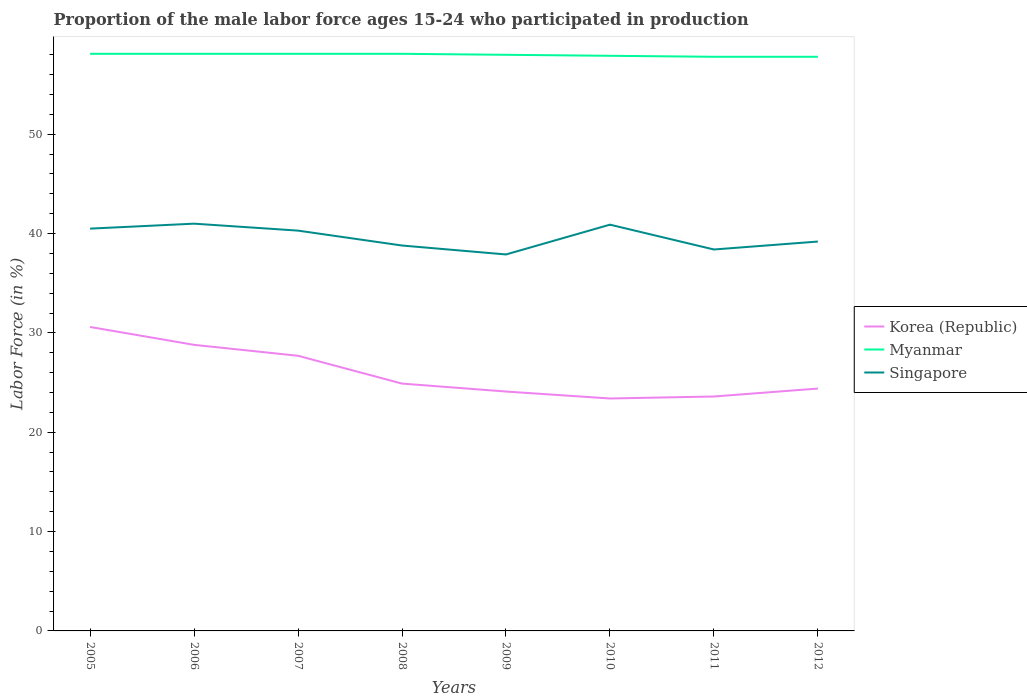How many different coloured lines are there?
Your response must be concise. 3. Is the number of lines equal to the number of legend labels?
Give a very brief answer. Yes. Across all years, what is the maximum proportion of the male labor force who participated in production in Singapore?
Provide a succinct answer. 37.9. In which year was the proportion of the male labor force who participated in production in Korea (Republic) maximum?
Keep it short and to the point. 2010. What is the difference between the highest and the second highest proportion of the male labor force who participated in production in Singapore?
Offer a very short reply. 3.1. Is the proportion of the male labor force who participated in production in Myanmar strictly greater than the proportion of the male labor force who participated in production in Singapore over the years?
Make the answer very short. No. How many lines are there?
Your answer should be compact. 3. Where does the legend appear in the graph?
Provide a short and direct response. Center right. How are the legend labels stacked?
Provide a short and direct response. Vertical. What is the title of the graph?
Keep it short and to the point. Proportion of the male labor force ages 15-24 who participated in production. Does "East Asia (all income levels)" appear as one of the legend labels in the graph?
Offer a terse response. No. What is the label or title of the X-axis?
Provide a short and direct response. Years. What is the label or title of the Y-axis?
Offer a very short reply. Labor Force (in %). What is the Labor Force (in %) of Korea (Republic) in 2005?
Offer a very short reply. 30.6. What is the Labor Force (in %) of Myanmar in 2005?
Your response must be concise. 58.1. What is the Labor Force (in %) of Singapore in 2005?
Provide a succinct answer. 40.5. What is the Labor Force (in %) of Korea (Republic) in 2006?
Your response must be concise. 28.8. What is the Labor Force (in %) of Myanmar in 2006?
Offer a terse response. 58.1. What is the Labor Force (in %) of Korea (Republic) in 2007?
Your answer should be very brief. 27.7. What is the Labor Force (in %) in Myanmar in 2007?
Ensure brevity in your answer.  58.1. What is the Labor Force (in %) of Singapore in 2007?
Provide a short and direct response. 40.3. What is the Labor Force (in %) in Korea (Republic) in 2008?
Give a very brief answer. 24.9. What is the Labor Force (in %) of Myanmar in 2008?
Offer a very short reply. 58.1. What is the Labor Force (in %) of Singapore in 2008?
Your response must be concise. 38.8. What is the Labor Force (in %) in Korea (Republic) in 2009?
Provide a succinct answer. 24.1. What is the Labor Force (in %) of Singapore in 2009?
Make the answer very short. 37.9. What is the Labor Force (in %) of Korea (Republic) in 2010?
Provide a short and direct response. 23.4. What is the Labor Force (in %) of Myanmar in 2010?
Your answer should be very brief. 57.9. What is the Labor Force (in %) in Singapore in 2010?
Give a very brief answer. 40.9. What is the Labor Force (in %) of Korea (Republic) in 2011?
Make the answer very short. 23.6. What is the Labor Force (in %) in Myanmar in 2011?
Provide a succinct answer. 57.8. What is the Labor Force (in %) in Singapore in 2011?
Offer a terse response. 38.4. What is the Labor Force (in %) in Korea (Republic) in 2012?
Your response must be concise. 24.4. What is the Labor Force (in %) in Myanmar in 2012?
Give a very brief answer. 57.8. What is the Labor Force (in %) of Singapore in 2012?
Provide a succinct answer. 39.2. Across all years, what is the maximum Labor Force (in %) of Korea (Republic)?
Offer a very short reply. 30.6. Across all years, what is the maximum Labor Force (in %) in Myanmar?
Provide a short and direct response. 58.1. Across all years, what is the minimum Labor Force (in %) in Korea (Republic)?
Keep it short and to the point. 23.4. Across all years, what is the minimum Labor Force (in %) in Myanmar?
Provide a succinct answer. 57.8. Across all years, what is the minimum Labor Force (in %) in Singapore?
Offer a very short reply. 37.9. What is the total Labor Force (in %) in Korea (Republic) in the graph?
Your answer should be very brief. 207.5. What is the total Labor Force (in %) in Myanmar in the graph?
Ensure brevity in your answer.  463.9. What is the total Labor Force (in %) of Singapore in the graph?
Keep it short and to the point. 317. What is the difference between the Labor Force (in %) in Singapore in 2005 and that in 2006?
Your answer should be very brief. -0.5. What is the difference between the Labor Force (in %) in Singapore in 2005 and that in 2007?
Offer a very short reply. 0.2. What is the difference between the Labor Force (in %) of Myanmar in 2005 and that in 2009?
Provide a succinct answer. 0.1. What is the difference between the Labor Force (in %) in Singapore in 2005 and that in 2009?
Provide a succinct answer. 2.6. What is the difference between the Labor Force (in %) in Korea (Republic) in 2005 and that in 2010?
Provide a succinct answer. 7.2. What is the difference between the Labor Force (in %) of Korea (Republic) in 2005 and that in 2011?
Your answer should be very brief. 7. What is the difference between the Labor Force (in %) of Myanmar in 2005 and that in 2011?
Make the answer very short. 0.3. What is the difference between the Labor Force (in %) of Korea (Republic) in 2005 and that in 2012?
Provide a short and direct response. 6.2. What is the difference between the Labor Force (in %) in Myanmar in 2005 and that in 2012?
Provide a succinct answer. 0.3. What is the difference between the Labor Force (in %) in Singapore in 2005 and that in 2012?
Provide a short and direct response. 1.3. What is the difference between the Labor Force (in %) in Korea (Republic) in 2006 and that in 2007?
Offer a terse response. 1.1. What is the difference between the Labor Force (in %) of Singapore in 2006 and that in 2007?
Give a very brief answer. 0.7. What is the difference between the Labor Force (in %) in Korea (Republic) in 2006 and that in 2009?
Offer a very short reply. 4.7. What is the difference between the Labor Force (in %) of Myanmar in 2006 and that in 2009?
Your answer should be very brief. 0.1. What is the difference between the Labor Force (in %) of Korea (Republic) in 2006 and that in 2010?
Ensure brevity in your answer.  5.4. What is the difference between the Labor Force (in %) in Myanmar in 2006 and that in 2010?
Your answer should be compact. 0.2. What is the difference between the Labor Force (in %) of Myanmar in 2006 and that in 2011?
Offer a terse response. 0.3. What is the difference between the Labor Force (in %) of Korea (Republic) in 2006 and that in 2012?
Your answer should be very brief. 4.4. What is the difference between the Labor Force (in %) of Korea (Republic) in 2007 and that in 2008?
Offer a very short reply. 2.8. What is the difference between the Labor Force (in %) in Myanmar in 2007 and that in 2009?
Provide a succinct answer. 0.1. What is the difference between the Labor Force (in %) of Korea (Republic) in 2007 and that in 2010?
Ensure brevity in your answer.  4.3. What is the difference between the Labor Force (in %) in Korea (Republic) in 2007 and that in 2011?
Give a very brief answer. 4.1. What is the difference between the Labor Force (in %) in Myanmar in 2007 and that in 2011?
Your answer should be very brief. 0.3. What is the difference between the Labor Force (in %) in Korea (Republic) in 2007 and that in 2012?
Make the answer very short. 3.3. What is the difference between the Labor Force (in %) in Singapore in 2007 and that in 2012?
Give a very brief answer. 1.1. What is the difference between the Labor Force (in %) in Singapore in 2008 and that in 2009?
Keep it short and to the point. 0.9. What is the difference between the Labor Force (in %) in Korea (Republic) in 2008 and that in 2010?
Ensure brevity in your answer.  1.5. What is the difference between the Labor Force (in %) in Korea (Republic) in 2008 and that in 2011?
Keep it short and to the point. 1.3. What is the difference between the Labor Force (in %) of Singapore in 2008 and that in 2011?
Provide a succinct answer. 0.4. What is the difference between the Labor Force (in %) in Korea (Republic) in 2008 and that in 2012?
Your response must be concise. 0.5. What is the difference between the Labor Force (in %) of Myanmar in 2008 and that in 2012?
Your answer should be compact. 0.3. What is the difference between the Labor Force (in %) of Singapore in 2008 and that in 2012?
Provide a short and direct response. -0.4. What is the difference between the Labor Force (in %) of Myanmar in 2009 and that in 2010?
Offer a very short reply. 0.1. What is the difference between the Labor Force (in %) of Myanmar in 2009 and that in 2011?
Provide a short and direct response. 0.2. What is the difference between the Labor Force (in %) of Singapore in 2009 and that in 2011?
Make the answer very short. -0.5. What is the difference between the Labor Force (in %) in Korea (Republic) in 2009 and that in 2012?
Provide a succinct answer. -0.3. What is the difference between the Labor Force (in %) in Singapore in 2009 and that in 2012?
Keep it short and to the point. -1.3. What is the difference between the Labor Force (in %) of Korea (Republic) in 2010 and that in 2011?
Provide a succinct answer. -0.2. What is the difference between the Labor Force (in %) of Myanmar in 2010 and that in 2011?
Keep it short and to the point. 0.1. What is the difference between the Labor Force (in %) of Myanmar in 2010 and that in 2012?
Your answer should be compact. 0.1. What is the difference between the Labor Force (in %) of Singapore in 2010 and that in 2012?
Make the answer very short. 1.7. What is the difference between the Labor Force (in %) in Korea (Republic) in 2011 and that in 2012?
Keep it short and to the point. -0.8. What is the difference between the Labor Force (in %) in Myanmar in 2011 and that in 2012?
Make the answer very short. 0. What is the difference between the Labor Force (in %) of Singapore in 2011 and that in 2012?
Keep it short and to the point. -0.8. What is the difference between the Labor Force (in %) of Korea (Republic) in 2005 and the Labor Force (in %) of Myanmar in 2006?
Give a very brief answer. -27.5. What is the difference between the Labor Force (in %) of Myanmar in 2005 and the Labor Force (in %) of Singapore in 2006?
Offer a terse response. 17.1. What is the difference between the Labor Force (in %) of Korea (Republic) in 2005 and the Labor Force (in %) of Myanmar in 2007?
Keep it short and to the point. -27.5. What is the difference between the Labor Force (in %) in Korea (Republic) in 2005 and the Labor Force (in %) in Myanmar in 2008?
Your answer should be compact. -27.5. What is the difference between the Labor Force (in %) of Korea (Republic) in 2005 and the Labor Force (in %) of Singapore in 2008?
Your response must be concise. -8.2. What is the difference between the Labor Force (in %) in Myanmar in 2005 and the Labor Force (in %) in Singapore in 2008?
Give a very brief answer. 19.3. What is the difference between the Labor Force (in %) of Korea (Republic) in 2005 and the Labor Force (in %) of Myanmar in 2009?
Your answer should be very brief. -27.4. What is the difference between the Labor Force (in %) of Korea (Republic) in 2005 and the Labor Force (in %) of Singapore in 2009?
Provide a succinct answer. -7.3. What is the difference between the Labor Force (in %) of Myanmar in 2005 and the Labor Force (in %) of Singapore in 2009?
Provide a short and direct response. 20.2. What is the difference between the Labor Force (in %) in Korea (Republic) in 2005 and the Labor Force (in %) in Myanmar in 2010?
Make the answer very short. -27.3. What is the difference between the Labor Force (in %) in Myanmar in 2005 and the Labor Force (in %) in Singapore in 2010?
Offer a very short reply. 17.2. What is the difference between the Labor Force (in %) in Korea (Republic) in 2005 and the Labor Force (in %) in Myanmar in 2011?
Offer a very short reply. -27.2. What is the difference between the Labor Force (in %) in Korea (Republic) in 2005 and the Labor Force (in %) in Singapore in 2011?
Ensure brevity in your answer.  -7.8. What is the difference between the Labor Force (in %) of Myanmar in 2005 and the Labor Force (in %) of Singapore in 2011?
Make the answer very short. 19.7. What is the difference between the Labor Force (in %) of Korea (Republic) in 2005 and the Labor Force (in %) of Myanmar in 2012?
Make the answer very short. -27.2. What is the difference between the Labor Force (in %) in Myanmar in 2005 and the Labor Force (in %) in Singapore in 2012?
Your answer should be very brief. 18.9. What is the difference between the Labor Force (in %) in Korea (Republic) in 2006 and the Labor Force (in %) in Myanmar in 2007?
Keep it short and to the point. -29.3. What is the difference between the Labor Force (in %) of Korea (Republic) in 2006 and the Labor Force (in %) of Singapore in 2007?
Make the answer very short. -11.5. What is the difference between the Labor Force (in %) in Myanmar in 2006 and the Labor Force (in %) in Singapore in 2007?
Your response must be concise. 17.8. What is the difference between the Labor Force (in %) of Korea (Republic) in 2006 and the Labor Force (in %) of Myanmar in 2008?
Provide a succinct answer. -29.3. What is the difference between the Labor Force (in %) in Myanmar in 2006 and the Labor Force (in %) in Singapore in 2008?
Provide a succinct answer. 19.3. What is the difference between the Labor Force (in %) in Korea (Republic) in 2006 and the Labor Force (in %) in Myanmar in 2009?
Your answer should be very brief. -29.2. What is the difference between the Labor Force (in %) of Korea (Republic) in 2006 and the Labor Force (in %) of Singapore in 2009?
Provide a succinct answer. -9.1. What is the difference between the Labor Force (in %) in Myanmar in 2006 and the Labor Force (in %) in Singapore in 2009?
Your answer should be compact. 20.2. What is the difference between the Labor Force (in %) of Korea (Republic) in 2006 and the Labor Force (in %) of Myanmar in 2010?
Make the answer very short. -29.1. What is the difference between the Labor Force (in %) of Myanmar in 2006 and the Labor Force (in %) of Singapore in 2011?
Ensure brevity in your answer.  19.7. What is the difference between the Labor Force (in %) in Korea (Republic) in 2006 and the Labor Force (in %) in Singapore in 2012?
Offer a very short reply. -10.4. What is the difference between the Labor Force (in %) in Myanmar in 2006 and the Labor Force (in %) in Singapore in 2012?
Make the answer very short. 18.9. What is the difference between the Labor Force (in %) in Korea (Republic) in 2007 and the Labor Force (in %) in Myanmar in 2008?
Ensure brevity in your answer.  -30.4. What is the difference between the Labor Force (in %) of Myanmar in 2007 and the Labor Force (in %) of Singapore in 2008?
Your response must be concise. 19.3. What is the difference between the Labor Force (in %) in Korea (Republic) in 2007 and the Labor Force (in %) in Myanmar in 2009?
Offer a terse response. -30.3. What is the difference between the Labor Force (in %) in Myanmar in 2007 and the Labor Force (in %) in Singapore in 2009?
Ensure brevity in your answer.  20.2. What is the difference between the Labor Force (in %) of Korea (Republic) in 2007 and the Labor Force (in %) of Myanmar in 2010?
Offer a terse response. -30.2. What is the difference between the Labor Force (in %) in Korea (Republic) in 2007 and the Labor Force (in %) in Singapore in 2010?
Ensure brevity in your answer.  -13.2. What is the difference between the Labor Force (in %) of Myanmar in 2007 and the Labor Force (in %) of Singapore in 2010?
Give a very brief answer. 17.2. What is the difference between the Labor Force (in %) in Korea (Republic) in 2007 and the Labor Force (in %) in Myanmar in 2011?
Provide a succinct answer. -30.1. What is the difference between the Labor Force (in %) in Myanmar in 2007 and the Labor Force (in %) in Singapore in 2011?
Give a very brief answer. 19.7. What is the difference between the Labor Force (in %) of Korea (Republic) in 2007 and the Labor Force (in %) of Myanmar in 2012?
Make the answer very short. -30.1. What is the difference between the Labor Force (in %) of Korea (Republic) in 2007 and the Labor Force (in %) of Singapore in 2012?
Ensure brevity in your answer.  -11.5. What is the difference between the Labor Force (in %) of Myanmar in 2007 and the Labor Force (in %) of Singapore in 2012?
Ensure brevity in your answer.  18.9. What is the difference between the Labor Force (in %) in Korea (Republic) in 2008 and the Labor Force (in %) in Myanmar in 2009?
Provide a succinct answer. -33.1. What is the difference between the Labor Force (in %) in Myanmar in 2008 and the Labor Force (in %) in Singapore in 2009?
Offer a terse response. 20.2. What is the difference between the Labor Force (in %) of Korea (Republic) in 2008 and the Labor Force (in %) of Myanmar in 2010?
Ensure brevity in your answer.  -33. What is the difference between the Labor Force (in %) of Korea (Republic) in 2008 and the Labor Force (in %) of Singapore in 2010?
Your answer should be compact. -16. What is the difference between the Labor Force (in %) of Korea (Republic) in 2008 and the Labor Force (in %) of Myanmar in 2011?
Give a very brief answer. -32.9. What is the difference between the Labor Force (in %) in Myanmar in 2008 and the Labor Force (in %) in Singapore in 2011?
Provide a short and direct response. 19.7. What is the difference between the Labor Force (in %) of Korea (Republic) in 2008 and the Labor Force (in %) of Myanmar in 2012?
Offer a very short reply. -32.9. What is the difference between the Labor Force (in %) of Korea (Republic) in 2008 and the Labor Force (in %) of Singapore in 2012?
Provide a succinct answer. -14.3. What is the difference between the Labor Force (in %) of Korea (Republic) in 2009 and the Labor Force (in %) of Myanmar in 2010?
Ensure brevity in your answer.  -33.8. What is the difference between the Labor Force (in %) of Korea (Republic) in 2009 and the Labor Force (in %) of Singapore in 2010?
Offer a very short reply. -16.8. What is the difference between the Labor Force (in %) of Myanmar in 2009 and the Labor Force (in %) of Singapore in 2010?
Offer a terse response. 17.1. What is the difference between the Labor Force (in %) of Korea (Republic) in 2009 and the Labor Force (in %) of Myanmar in 2011?
Offer a very short reply. -33.7. What is the difference between the Labor Force (in %) in Korea (Republic) in 2009 and the Labor Force (in %) in Singapore in 2011?
Make the answer very short. -14.3. What is the difference between the Labor Force (in %) in Myanmar in 2009 and the Labor Force (in %) in Singapore in 2011?
Make the answer very short. 19.6. What is the difference between the Labor Force (in %) in Korea (Republic) in 2009 and the Labor Force (in %) in Myanmar in 2012?
Provide a succinct answer. -33.7. What is the difference between the Labor Force (in %) of Korea (Republic) in 2009 and the Labor Force (in %) of Singapore in 2012?
Make the answer very short. -15.1. What is the difference between the Labor Force (in %) in Korea (Republic) in 2010 and the Labor Force (in %) in Myanmar in 2011?
Your answer should be compact. -34.4. What is the difference between the Labor Force (in %) in Korea (Republic) in 2010 and the Labor Force (in %) in Myanmar in 2012?
Ensure brevity in your answer.  -34.4. What is the difference between the Labor Force (in %) of Korea (Republic) in 2010 and the Labor Force (in %) of Singapore in 2012?
Offer a very short reply. -15.8. What is the difference between the Labor Force (in %) in Korea (Republic) in 2011 and the Labor Force (in %) in Myanmar in 2012?
Your answer should be very brief. -34.2. What is the difference between the Labor Force (in %) of Korea (Republic) in 2011 and the Labor Force (in %) of Singapore in 2012?
Provide a short and direct response. -15.6. What is the difference between the Labor Force (in %) in Myanmar in 2011 and the Labor Force (in %) in Singapore in 2012?
Ensure brevity in your answer.  18.6. What is the average Labor Force (in %) of Korea (Republic) per year?
Provide a short and direct response. 25.94. What is the average Labor Force (in %) of Myanmar per year?
Keep it short and to the point. 57.99. What is the average Labor Force (in %) in Singapore per year?
Make the answer very short. 39.62. In the year 2005, what is the difference between the Labor Force (in %) of Korea (Republic) and Labor Force (in %) of Myanmar?
Offer a terse response. -27.5. In the year 2005, what is the difference between the Labor Force (in %) of Myanmar and Labor Force (in %) of Singapore?
Give a very brief answer. 17.6. In the year 2006, what is the difference between the Labor Force (in %) of Korea (Republic) and Labor Force (in %) of Myanmar?
Give a very brief answer. -29.3. In the year 2007, what is the difference between the Labor Force (in %) of Korea (Republic) and Labor Force (in %) of Myanmar?
Provide a succinct answer. -30.4. In the year 2007, what is the difference between the Labor Force (in %) in Korea (Republic) and Labor Force (in %) in Singapore?
Make the answer very short. -12.6. In the year 2007, what is the difference between the Labor Force (in %) in Myanmar and Labor Force (in %) in Singapore?
Ensure brevity in your answer.  17.8. In the year 2008, what is the difference between the Labor Force (in %) of Korea (Republic) and Labor Force (in %) of Myanmar?
Give a very brief answer. -33.2. In the year 2008, what is the difference between the Labor Force (in %) in Myanmar and Labor Force (in %) in Singapore?
Your response must be concise. 19.3. In the year 2009, what is the difference between the Labor Force (in %) in Korea (Republic) and Labor Force (in %) in Myanmar?
Your answer should be very brief. -33.9. In the year 2009, what is the difference between the Labor Force (in %) in Korea (Republic) and Labor Force (in %) in Singapore?
Your answer should be very brief. -13.8. In the year 2009, what is the difference between the Labor Force (in %) in Myanmar and Labor Force (in %) in Singapore?
Provide a short and direct response. 20.1. In the year 2010, what is the difference between the Labor Force (in %) of Korea (Republic) and Labor Force (in %) of Myanmar?
Offer a very short reply. -34.5. In the year 2010, what is the difference between the Labor Force (in %) of Korea (Republic) and Labor Force (in %) of Singapore?
Provide a succinct answer. -17.5. In the year 2010, what is the difference between the Labor Force (in %) of Myanmar and Labor Force (in %) of Singapore?
Make the answer very short. 17. In the year 2011, what is the difference between the Labor Force (in %) of Korea (Republic) and Labor Force (in %) of Myanmar?
Give a very brief answer. -34.2. In the year 2011, what is the difference between the Labor Force (in %) in Korea (Republic) and Labor Force (in %) in Singapore?
Your response must be concise. -14.8. In the year 2011, what is the difference between the Labor Force (in %) of Myanmar and Labor Force (in %) of Singapore?
Make the answer very short. 19.4. In the year 2012, what is the difference between the Labor Force (in %) of Korea (Republic) and Labor Force (in %) of Myanmar?
Ensure brevity in your answer.  -33.4. In the year 2012, what is the difference between the Labor Force (in %) in Korea (Republic) and Labor Force (in %) in Singapore?
Give a very brief answer. -14.8. In the year 2012, what is the difference between the Labor Force (in %) in Myanmar and Labor Force (in %) in Singapore?
Give a very brief answer. 18.6. What is the ratio of the Labor Force (in %) of Korea (Republic) in 2005 to that in 2007?
Ensure brevity in your answer.  1.1. What is the ratio of the Labor Force (in %) of Singapore in 2005 to that in 2007?
Your answer should be compact. 1. What is the ratio of the Labor Force (in %) of Korea (Republic) in 2005 to that in 2008?
Ensure brevity in your answer.  1.23. What is the ratio of the Labor Force (in %) of Singapore in 2005 to that in 2008?
Your answer should be very brief. 1.04. What is the ratio of the Labor Force (in %) of Korea (Republic) in 2005 to that in 2009?
Your answer should be compact. 1.27. What is the ratio of the Labor Force (in %) in Singapore in 2005 to that in 2009?
Make the answer very short. 1.07. What is the ratio of the Labor Force (in %) in Korea (Republic) in 2005 to that in 2010?
Provide a short and direct response. 1.31. What is the ratio of the Labor Force (in %) in Singapore in 2005 to that in 2010?
Offer a terse response. 0.99. What is the ratio of the Labor Force (in %) in Korea (Republic) in 2005 to that in 2011?
Keep it short and to the point. 1.3. What is the ratio of the Labor Force (in %) in Singapore in 2005 to that in 2011?
Give a very brief answer. 1.05. What is the ratio of the Labor Force (in %) of Korea (Republic) in 2005 to that in 2012?
Provide a succinct answer. 1.25. What is the ratio of the Labor Force (in %) in Myanmar in 2005 to that in 2012?
Your answer should be compact. 1.01. What is the ratio of the Labor Force (in %) in Singapore in 2005 to that in 2012?
Ensure brevity in your answer.  1.03. What is the ratio of the Labor Force (in %) in Korea (Republic) in 2006 to that in 2007?
Your answer should be very brief. 1.04. What is the ratio of the Labor Force (in %) of Myanmar in 2006 to that in 2007?
Give a very brief answer. 1. What is the ratio of the Labor Force (in %) in Singapore in 2006 to that in 2007?
Provide a short and direct response. 1.02. What is the ratio of the Labor Force (in %) in Korea (Republic) in 2006 to that in 2008?
Offer a very short reply. 1.16. What is the ratio of the Labor Force (in %) of Myanmar in 2006 to that in 2008?
Provide a short and direct response. 1. What is the ratio of the Labor Force (in %) of Singapore in 2006 to that in 2008?
Make the answer very short. 1.06. What is the ratio of the Labor Force (in %) of Korea (Republic) in 2006 to that in 2009?
Ensure brevity in your answer.  1.2. What is the ratio of the Labor Force (in %) in Myanmar in 2006 to that in 2009?
Your answer should be very brief. 1. What is the ratio of the Labor Force (in %) in Singapore in 2006 to that in 2009?
Offer a terse response. 1.08. What is the ratio of the Labor Force (in %) of Korea (Republic) in 2006 to that in 2010?
Offer a very short reply. 1.23. What is the ratio of the Labor Force (in %) in Myanmar in 2006 to that in 2010?
Make the answer very short. 1. What is the ratio of the Labor Force (in %) of Singapore in 2006 to that in 2010?
Give a very brief answer. 1. What is the ratio of the Labor Force (in %) in Korea (Republic) in 2006 to that in 2011?
Give a very brief answer. 1.22. What is the ratio of the Labor Force (in %) of Myanmar in 2006 to that in 2011?
Provide a short and direct response. 1.01. What is the ratio of the Labor Force (in %) in Singapore in 2006 to that in 2011?
Provide a succinct answer. 1.07. What is the ratio of the Labor Force (in %) of Korea (Republic) in 2006 to that in 2012?
Make the answer very short. 1.18. What is the ratio of the Labor Force (in %) of Myanmar in 2006 to that in 2012?
Give a very brief answer. 1.01. What is the ratio of the Labor Force (in %) in Singapore in 2006 to that in 2012?
Give a very brief answer. 1.05. What is the ratio of the Labor Force (in %) in Korea (Republic) in 2007 to that in 2008?
Make the answer very short. 1.11. What is the ratio of the Labor Force (in %) of Myanmar in 2007 to that in 2008?
Your answer should be very brief. 1. What is the ratio of the Labor Force (in %) of Singapore in 2007 to that in 2008?
Make the answer very short. 1.04. What is the ratio of the Labor Force (in %) of Korea (Republic) in 2007 to that in 2009?
Provide a short and direct response. 1.15. What is the ratio of the Labor Force (in %) in Myanmar in 2007 to that in 2009?
Provide a short and direct response. 1. What is the ratio of the Labor Force (in %) in Singapore in 2007 to that in 2009?
Keep it short and to the point. 1.06. What is the ratio of the Labor Force (in %) in Korea (Republic) in 2007 to that in 2010?
Give a very brief answer. 1.18. What is the ratio of the Labor Force (in %) of Singapore in 2007 to that in 2010?
Provide a succinct answer. 0.99. What is the ratio of the Labor Force (in %) in Korea (Republic) in 2007 to that in 2011?
Offer a very short reply. 1.17. What is the ratio of the Labor Force (in %) of Myanmar in 2007 to that in 2011?
Provide a short and direct response. 1.01. What is the ratio of the Labor Force (in %) of Singapore in 2007 to that in 2011?
Provide a short and direct response. 1.05. What is the ratio of the Labor Force (in %) in Korea (Republic) in 2007 to that in 2012?
Make the answer very short. 1.14. What is the ratio of the Labor Force (in %) of Singapore in 2007 to that in 2012?
Make the answer very short. 1.03. What is the ratio of the Labor Force (in %) in Korea (Republic) in 2008 to that in 2009?
Keep it short and to the point. 1.03. What is the ratio of the Labor Force (in %) in Myanmar in 2008 to that in 2009?
Your answer should be compact. 1. What is the ratio of the Labor Force (in %) in Singapore in 2008 to that in 2009?
Your response must be concise. 1.02. What is the ratio of the Labor Force (in %) of Korea (Republic) in 2008 to that in 2010?
Keep it short and to the point. 1.06. What is the ratio of the Labor Force (in %) of Singapore in 2008 to that in 2010?
Make the answer very short. 0.95. What is the ratio of the Labor Force (in %) of Korea (Republic) in 2008 to that in 2011?
Your answer should be compact. 1.06. What is the ratio of the Labor Force (in %) of Singapore in 2008 to that in 2011?
Offer a terse response. 1.01. What is the ratio of the Labor Force (in %) in Korea (Republic) in 2008 to that in 2012?
Make the answer very short. 1.02. What is the ratio of the Labor Force (in %) in Singapore in 2008 to that in 2012?
Keep it short and to the point. 0.99. What is the ratio of the Labor Force (in %) in Korea (Republic) in 2009 to that in 2010?
Your answer should be compact. 1.03. What is the ratio of the Labor Force (in %) of Singapore in 2009 to that in 2010?
Provide a succinct answer. 0.93. What is the ratio of the Labor Force (in %) in Korea (Republic) in 2009 to that in 2011?
Provide a succinct answer. 1.02. What is the ratio of the Labor Force (in %) in Myanmar in 2009 to that in 2011?
Your answer should be compact. 1. What is the ratio of the Labor Force (in %) in Singapore in 2009 to that in 2011?
Offer a terse response. 0.99. What is the ratio of the Labor Force (in %) of Korea (Republic) in 2009 to that in 2012?
Provide a succinct answer. 0.99. What is the ratio of the Labor Force (in %) in Singapore in 2009 to that in 2012?
Keep it short and to the point. 0.97. What is the ratio of the Labor Force (in %) in Korea (Republic) in 2010 to that in 2011?
Ensure brevity in your answer.  0.99. What is the ratio of the Labor Force (in %) in Myanmar in 2010 to that in 2011?
Offer a terse response. 1. What is the ratio of the Labor Force (in %) of Singapore in 2010 to that in 2011?
Offer a terse response. 1.07. What is the ratio of the Labor Force (in %) of Singapore in 2010 to that in 2012?
Provide a succinct answer. 1.04. What is the ratio of the Labor Force (in %) in Korea (Republic) in 2011 to that in 2012?
Keep it short and to the point. 0.97. What is the ratio of the Labor Force (in %) in Singapore in 2011 to that in 2012?
Your response must be concise. 0.98. What is the difference between the highest and the second highest Labor Force (in %) of Myanmar?
Keep it short and to the point. 0. What is the difference between the highest and the second highest Labor Force (in %) of Singapore?
Your response must be concise. 0.1. What is the difference between the highest and the lowest Labor Force (in %) in Singapore?
Your answer should be compact. 3.1. 